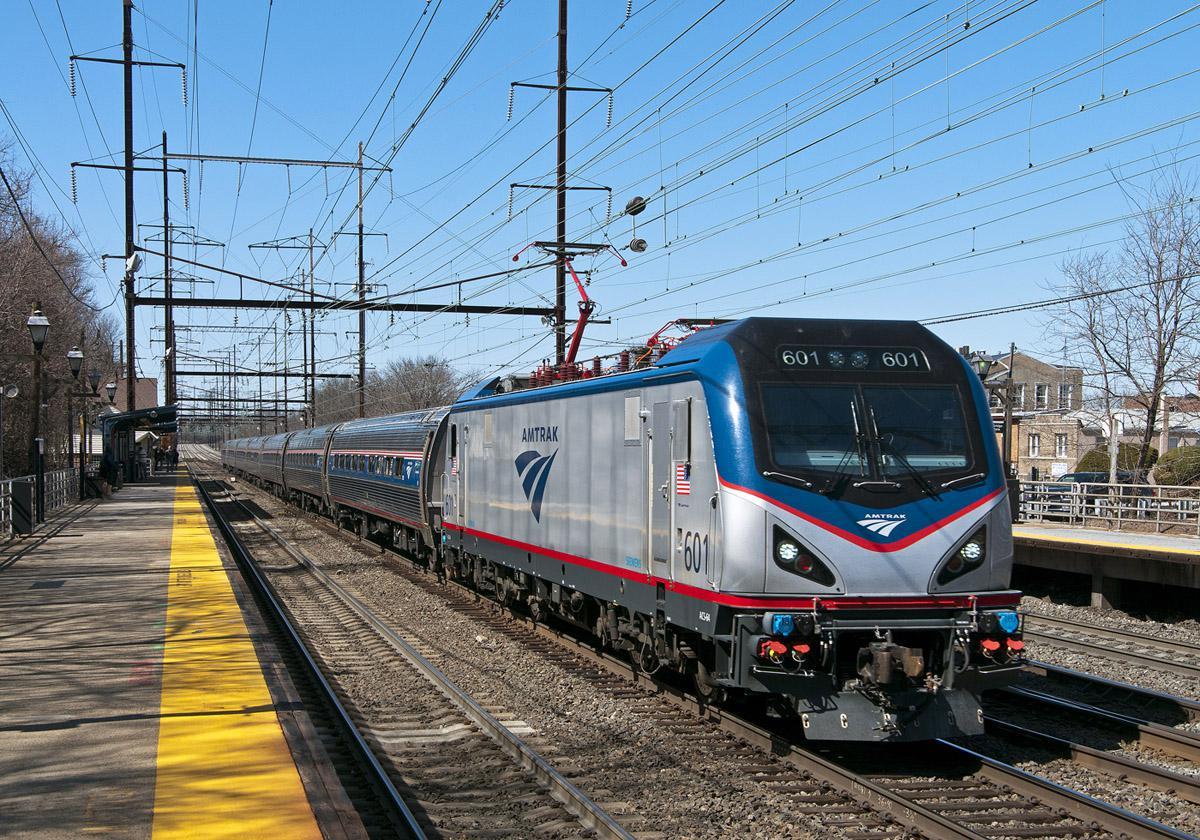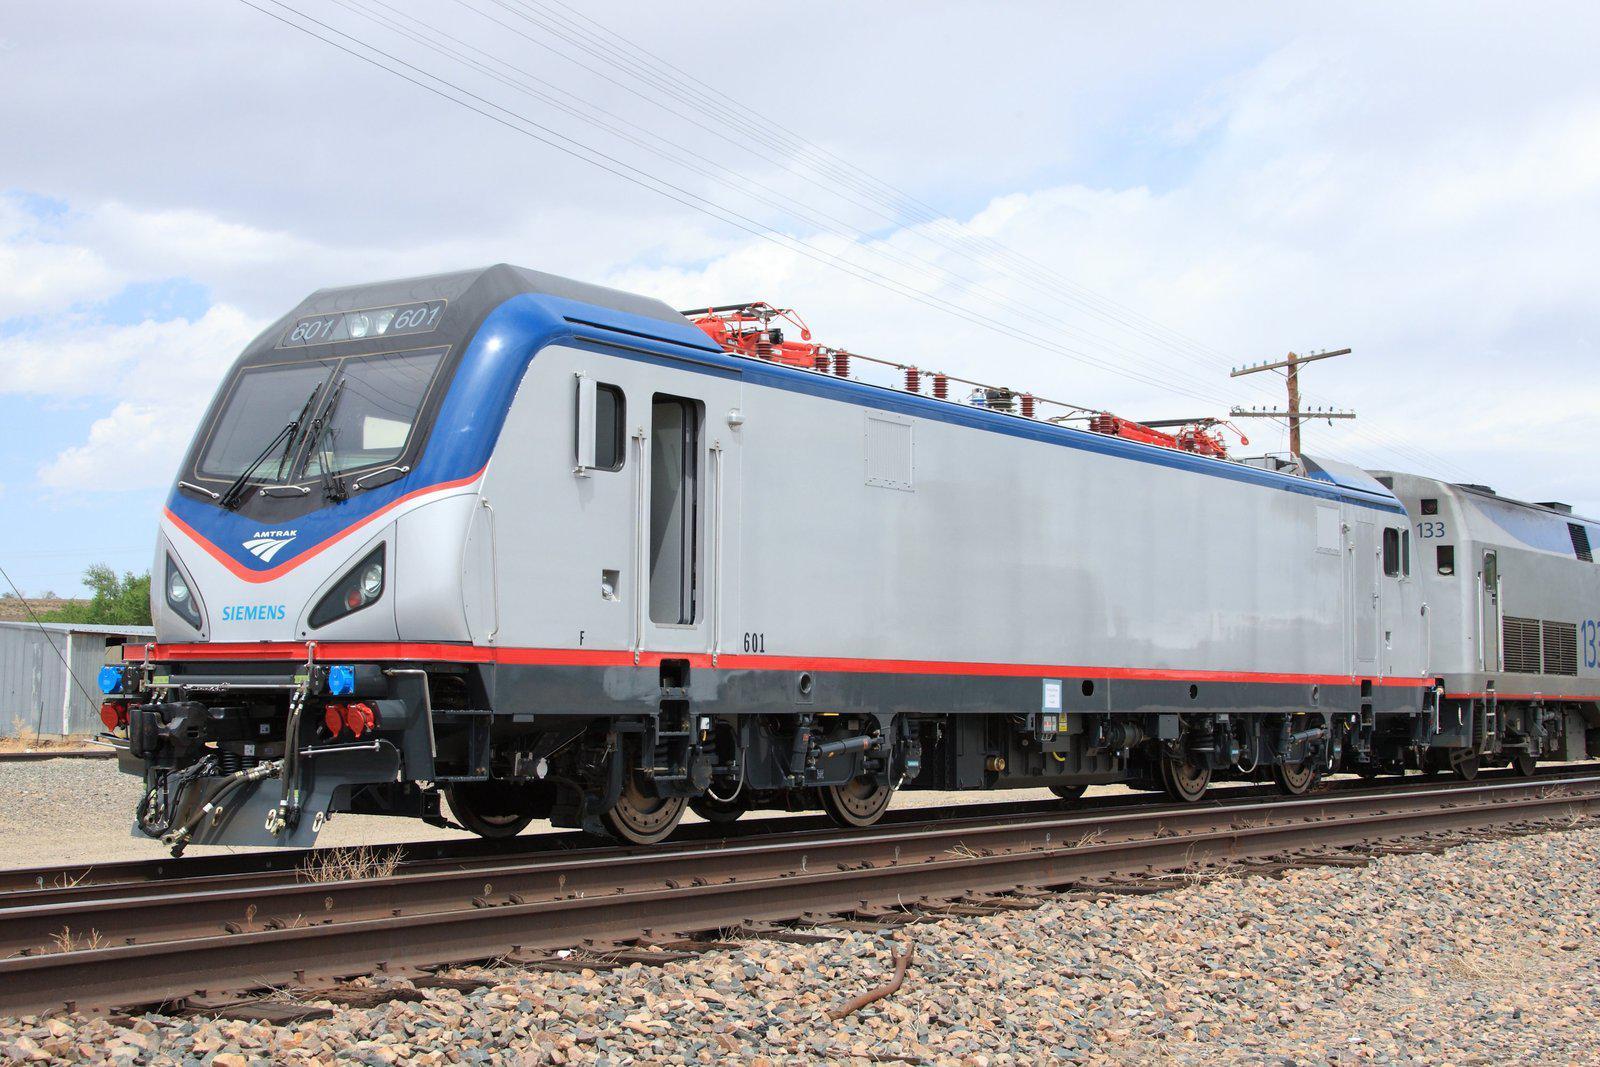The first image is the image on the left, the second image is the image on the right. Considering the images on both sides, is "There are at least six power poles in the image on the right." valid? Answer yes or no. No. 